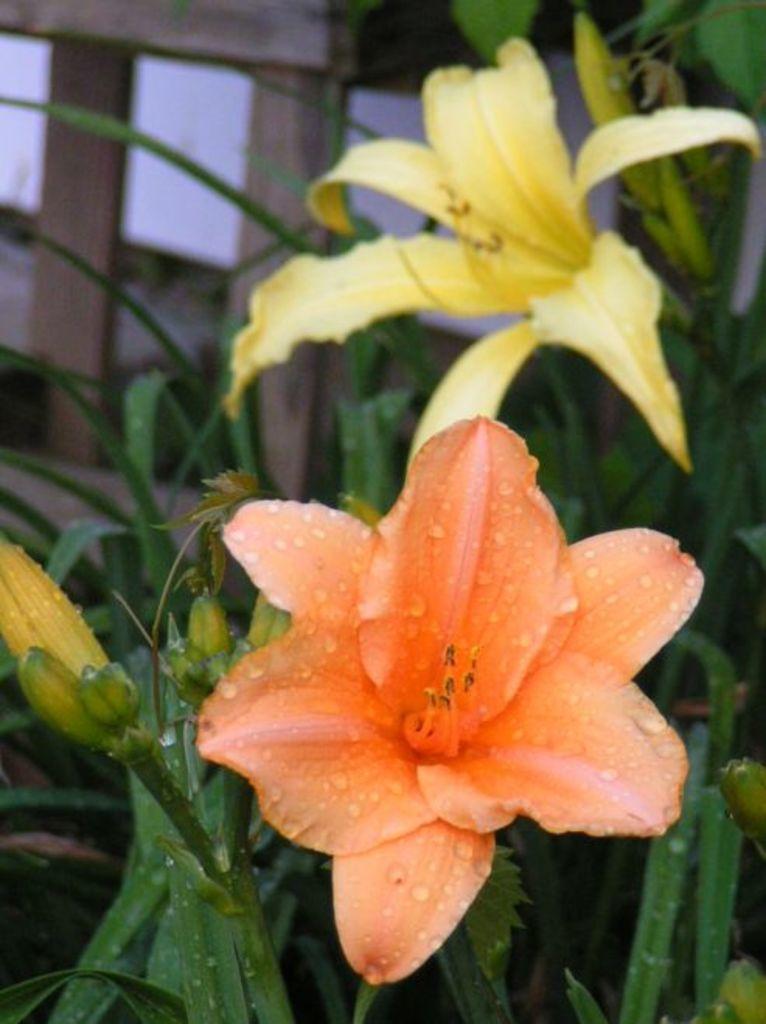Describe this image in one or two sentences. In this picture there is a yellow and orange flower. Behind we can see the fencing board. 